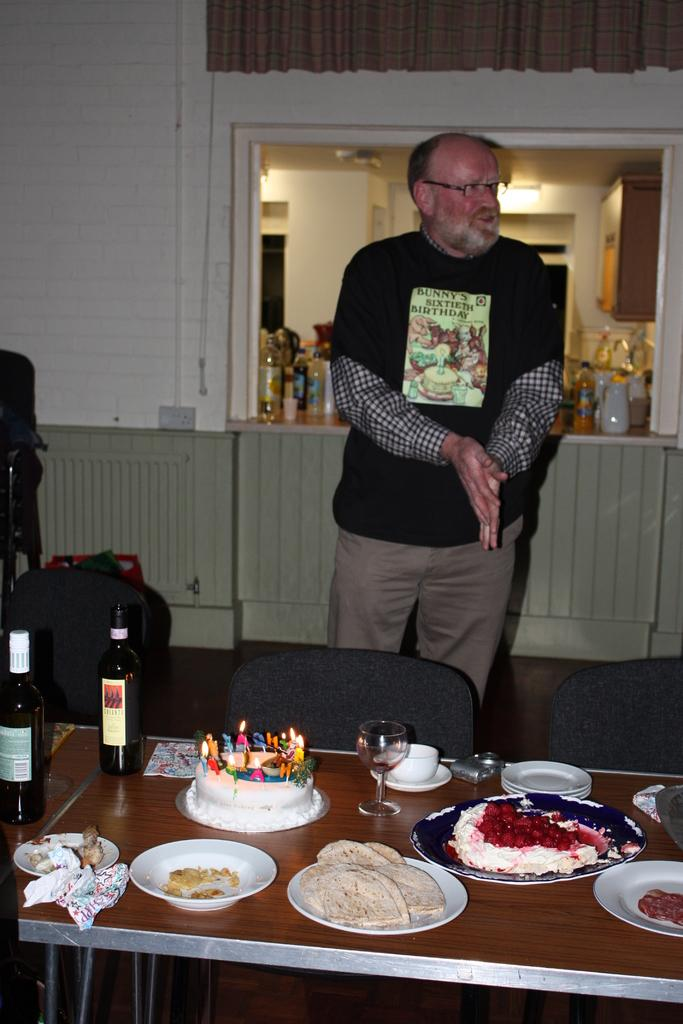What is the main subject of the image? There is a man in the image. What is the man doing in the image? The man is standing and rubbing his hands. What can be inferred about the setting of the image? The setting appears to be a dining room. What is on the table in the image? There is a table with a cake, wine bottles, glasses, and food on it. What type of vest is the man wearing in the image? The image does not show the man wearing a vest, so it cannot be determined from the image. 